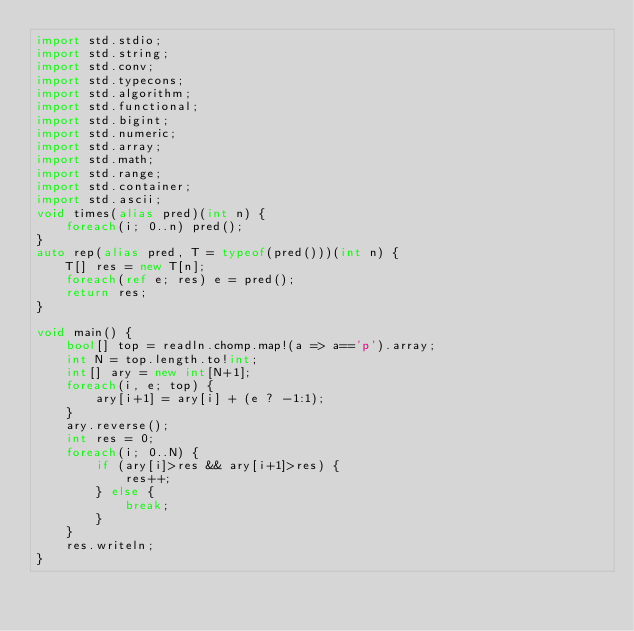Convert code to text. <code><loc_0><loc_0><loc_500><loc_500><_D_>import std.stdio;
import std.string;
import std.conv;
import std.typecons;
import std.algorithm;
import std.functional;
import std.bigint;
import std.numeric;
import std.array;
import std.math;
import std.range;
import std.container;
import std.ascii;
void times(alias pred)(int n) {
    foreach(i; 0..n) pred();
}
auto rep(alias pred, T = typeof(pred()))(int n) {
    T[] res = new T[n];
    foreach(ref e; res) e = pred();
    return res;
}

void main() {
    bool[] top = readln.chomp.map!(a => a=='p').array;
    int N = top.length.to!int;
    int[] ary = new int[N+1];
    foreach(i, e; top) {
        ary[i+1] = ary[i] + (e ? -1:1);
    }
    ary.reverse();
    int res = 0;
    foreach(i; 0..N) {
        if (ary[i]>res && ary[i+1]>res) {
            res++;
        } else {
            break;
        }
    }
    res.writeln;
}
</code> 